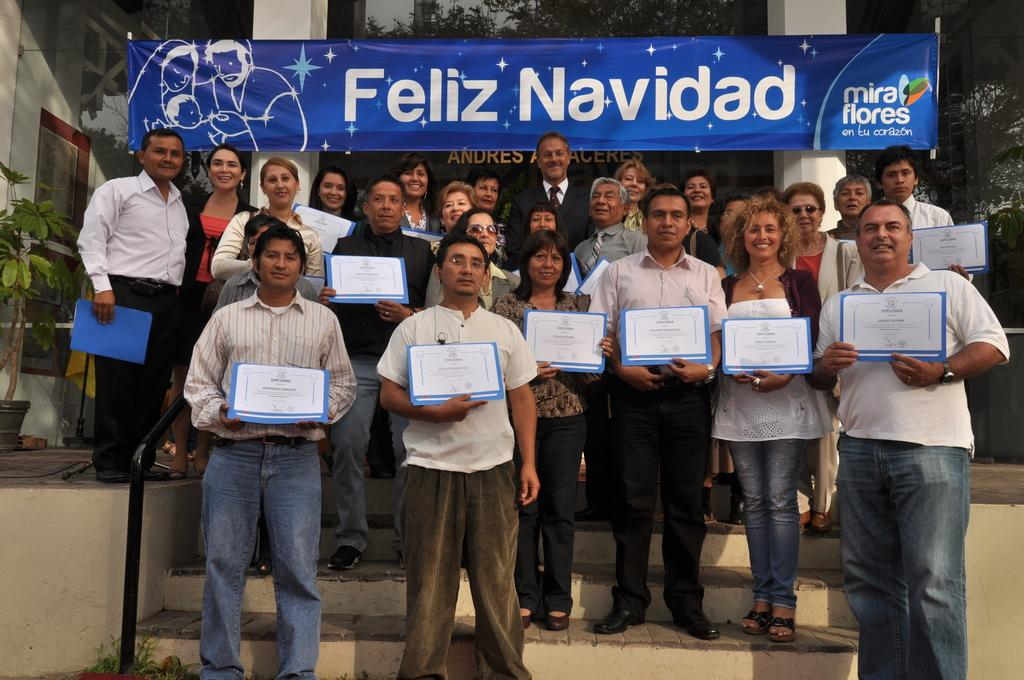How many people are in the image? There is a group of people in the image, but the exact number is not specified. What are the people doing in the image? The people are standing in the image. What are the people holding in their hands? The people are holding objects in their hands, but the specific objects are not described. What can be seen in the background of the image? There are pillars, plants, and other objects visible in the background of the image. What type of cub is visible in the image? There is no cub present in the image. What route are the people taking in the image? The image does not show the people taking any specific route; they are simply standing. 